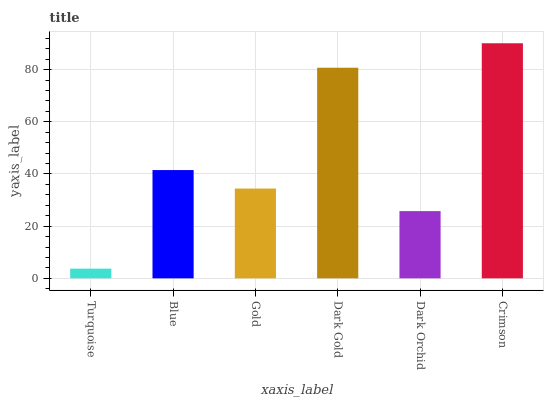Is Turquoise the minimum?
Answer yes or no. Yes. Is Crimson the maximum?
Answer yes or no. Yes. Is Blue the minimum?
Answer yes or no. No. Is Blue the maximum?
Answer yes or no. No. Is Blue greater than Turquoise?
Answer yes or no. Yes. Is Turquoise less than Blue?
Answer yes or no. Yes. Is Turquoise greater than Blue?
Answer yes or no. No. Is Blue less than Turquoise?
Answer yes or no. No. Is Blue the high median?
Answer yes or no. Yes. Is Gold the low median?
Answer yes or no. Yes. Is Crimson the high median?
Answer yes or no. No. Is Turquoise the low median?
Answer yes or no. No. 